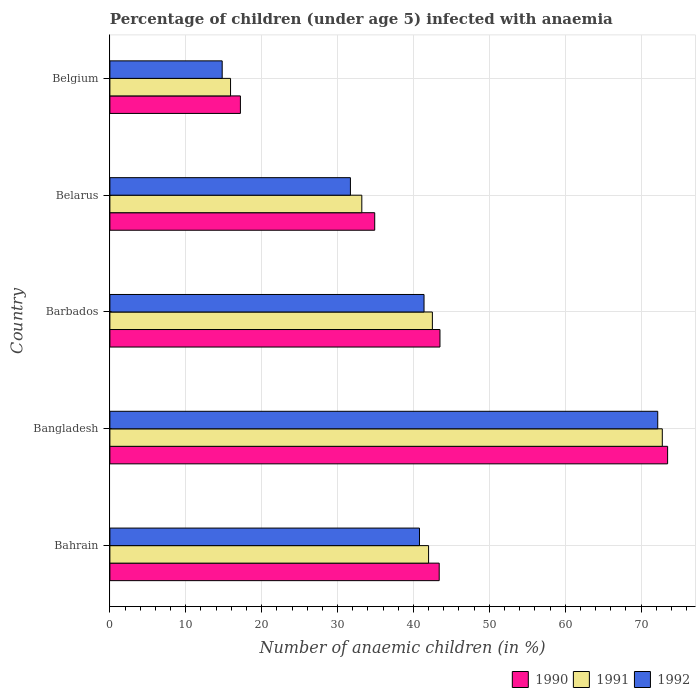Are the number of bars per tick equal to the number of legend labels?
Your answer should be very brief. Yes. How many bars are there on the 3rd tick from the top?
Make the answer very short. 3. How many bars are there on the 2nd tick from the bottom?
Your answer should be compact. 3. What is the label of the 5th group of bars from the top?
Provide a succinct answer. Bahrain. In how many cases, is the number of bars for a given country not equal to the number of legend labels?
Provide a short and direct response. 0. What is the percentage of children infected with anaemia in in 1990 in Belarus?
Ensure brevity in your answer.  34.9. Across all countries, what is the maximum percentage of children infected with anaemia in in 1991?
Your response must be concise. 72.8. Across all countries, what is the minimum percentage of children infected with anaemia in in 1991?
Your response must be concise. 15.9. What is the total percentage of children infected with anaemia in in 1991 in the graph?
Make the answer very short. 206.4. What is the difference between the percentage of children infected with anaemia in in 1991 in Bangladesh and that in Barbados?
Keep it short and to the point. 30.3. What is the difference between the percentage of children infected with anaemia in in 1991 in Bangladesh and the percentage of children infected with anaemia in in 1992 in Barbados?
Give a very brief answer. 31.4. What is the average percentage of children infected with anaemia in in 1991 per country?
Keep it short and to the point. 41.28. What is the difference between the percentage of children infected with anaemia in in 1990 and percentage of children infected with anaemia in in 1991 in Bangladesh?
Give a very brief answer. 0.7. In how many countries, is the percentage of children infected with anaemia in in 1991 greater than 16 %?
Provide a short and direct response. 4. What is the ratio of the percentage of children infected with anaemia in in 1990 in Belarus to that in Belgium?
Give a very brief answer. 2.03. Is the percentage of children infected with anaemia in in 1991 in Bangladesh less than that in Belarus?
Give a very brief answer. No. What is the difference between the highest and the lowest percentage of children infected with anaemia in in 1992?
Provide a succinct answer. 57.4. Is the sum of the percentage of children infected with anaemia in in 1992 in Bahrain and Belarus greater than the maximum percentage of children infected with anaemia in in 1990 across all countries?
Provide a succinct answer. No. What does the 2nd bar from the top in Bahrain represents?
Offer a very short reply. 1991. Is it the case that in every country, the sum of the percentage of children infected with anaemia in in 1990 and percentage of children infected with anaemia in in 1992 is greater than the percentage of children infected with anaemia in in 1991?
Provide a short and direct response. Yes. What is the difference between two consecutive major ticks on the X-axis?
Your response must be concise. 10. Does the graph contain grids?
Your response must be concise. Yes. How many legend labels are there?
Provide a short and direct response. 3. What is the title of the graph?
Provide a short and direct response. Percentage of children (under age 5) infected with anaemia. What is the label or title of the X-axis?
Keep it short and to the point. Number of anaemic children (in %). What is the label or title of the Y-axis?
Give a very brief answer. Country. What is the Number of anaemic children (in %) in 1990 in Bahrain?
Keep it short and to the point. 43.4. What is the Number of anaemic children (in %) in 1992 in Bahrain?
Your answer should be compact. 40.8. What is the Number of anaemic children (in %) in 1990 in Bangladesh?
Offer a terse response. 73.5. What is the Number of anaemic children (in %) in 1991 in Bangladesh?
Keep it short and to the point. 72.8. What is the Number of anaemic children (in %) of 1992 in Bangladesh?
Provide a succinct answer. 72.2. What is the Number of anaemic children (in %) of 1990 in Barbados?
Make the answer very short. 43.5. What is the Number of anaemic children (in %) of 1991 in Barbados?
Your answer should be compact. 42.5. What is the Number of anaemic children (in %) in 1992 in Barbados?
Your answer should be very brief. 41.4. What is the Number of anaemic children (in %) of 1990 in Belarus?
Ensure brevity in your answer.  34.9. What is the Number of anaemic children (in %) of 1991 in Belarus?
Provide a succinct answer. 33.2. What is the Number of anaemic children (in %) of 1992 in Belarus?
Give a very brief answer. 31.7. What is the Number of anaemic children (in %) in 1990 in Belgium?
Keep it short and to the point. 17.2. What is the Number of anaemic children (in %) in 1991 in Belgium?
Give a very brief answer. 15.9. What is the Number of anaemic children (in %) in 1992 in Belgium?
Your response must be concise. 14.8. Across all countries, what is the maximum Number of anaemic children (in %) of 1990?
Your answer should be very brief. 73.5. Across all countries, what is the maximum Number of anaemic children (in %) in 1991?
Provide a short and direct response. 72.8. Across all countries, what is the maximum Number of anaemic children (in %) of 1992?
Offer a terse response. 72.2. Across all countries, what is the minimum Number of anaemic children (in %) of 1990?
Keep it short and to the point. 17.2. Across all countries, what is the minimum Number of anaemic children (in %) in 1991?
Offer a very short reply. 15.9. Across all countries, what is the minimum Number of anaemic children (in %) in 1992?
Ensure brevity in your answer.  14.8. What is the total Number of anaemic children (in %) in 1990 in the graph?
Provide a succinct answer. 212.5. What is the total Number of anaemic children (in %) of 1991 in the graph?
Your answer should be very brief. 206.4. What is the total Number of anaemic children (in %) in 1992 in the graph?
Make the answer very short. 200.9. What is the difference between the Number of anaemic children (in %) of 1990 in Bahrain and that in Bangladesh?
Make the answer very short. -30.1. What is the difference between the Number of anaemic children (in %) in 1991 in Bahrain and that in Bangladesh?
Keep it short and to the point. -30.8. What is the difference between the Number of anaemic children (in %) of 1992 in Bahrain and that in Bangladesh?
Provide a short and direct response. -31.4. What is the difference between the Number of anaemic children (in %) in 1990 in Bahrain and that in Barbados?
Ensure brevity in your answer.  -0.1. What is the difference between the Number of anaemic children (in %) in 1990 in Bahrain and that in Belarus?
Your response must be concise. 8.5. What is the difference between the Number of anaemic children (in %) in 1991 in Bahrain and that in Belarus?
Ensure brevity in your answer.  8.8. What is the difference between the Number of anaemic children (in %) of 1990 in Bahrain and that in Belgium?
Offer a terse response. 26.2. What is the difference between the Number of anaemic children (in %) of 1991 in Bahrain and that in Belgium?
Keep it short and to the point. 26.1. What is the difference between the Number of anaemic children (in %) of 1992 in Bahrain and that in Belgium?
Provide a succinct answer. 26. What is the difference between the Number of anaemic children (in %) of 1990 in Bangladesh and that in Barbados?
Your answer should be very brief. 30. What is the difference between the Number of anaemic children (in %) of 1991 in Bangladesh and that in Barbados?
Give a very brief answer. 30.3. What is the difference between the Number of anaemic children (in %) in 1992 in Bangladesh and that in Barbados?
Your response must be concise. 30.8. What is the difference between the Number of anaemic children (in %) of 1990 in Bangladesh and that in Belarus?
Offer a terse response. 38.6. What is the difference between the Number of anaemic children (in %) in 1991 in Bangladesh and that in Belarus?
Your answer should be very brief. 39.6. What is the difference between the Number of anaemic children (in %) in 1992 in Bangladesh and that in Belarus?
Offer a very short reply. 40.5. What is the difference between the Number of anaemic children (in %) of 1990 in Bangladesh and that in Belgium?
Provide a short and direct response. 56.3. What is the difference between the Number of anaemic children (in %) in 1991 in Bangladesh and that in Belgium?
Give a very brief answer. 56.9. What is the difference between the Number of anaemic children (in %) of 1992 in Bangladesh and that in Belgium?
Offer a terse response. 57.4. What is the difference between the Number of anaemic children (in %) of 1990 in Barbados and that in Belarus?
Offer a very short reply. 8.6. What is the difference between the Number of anaemic children (in %) in 1991 in Barbados and that in Belarus?
Offer a very short reply. 9.3. What is the difference between the Number of anaemic children (in %) of 1990 in Barbados and that in Belgium?
Your answer should be compact. 26.3. What is the difference between the Number of anaemic children (in %) of 1991 in Barbados and that in Belgium?
Offer a terse response. 26.6. What is the difference between the Number of anaemic children (in %) in 1992 in Barbados and that in Belgium?
Ensure brevity in your answer.  26.6. What is the difference between the Number of anaemic children (in %) in 1990 in Belarus and that in Belgium?
Offer a terse response. 17.7. What is the difference between the Number of anaemic children (in %) of 1990 in Bahrain and the Number of anaemic children (in %) of 1991 in Bangladesh?
Give a very brief answer. -29.4. What is the difference between the Number of anaemic children (in %) in 1990 in Bahrain and the Number of anaemic children (in %) in 1992 in Bangladesh?
Give a very brief answer. -28.8. What is the difference between the Number of anaemic children (in %) of 1991 in Bahrain and the Number of anaemic children (in %) of 1992 in Bangladesh?
Your answer should be compact. -30.2. What is the difference between the Number of anaemic children (in %) in 1990 in Bahrain and the Number of anaemic children (in %) in 1991 in Barbados?
Provide a short and direct response. 0.9. What is the difference between the Number of anaemic children (in %) of 1990 in Bahrain and the Number of anaemic children (in %) of 1992 in Belarus?
Make the answer very short. 11.7. What is the difference between the Number of anaemic children (in %) in 1990 in Bahrain and the Number of anaemic children (in %) in 1992 in Belgium?
Keep it short and to the point. 28.6. What is the difference between the Number of anaemic children (in %) in 1991 in Bahrain and the Number of anaemic children (in %) in 1992 in Belgium?
Provide a succinct answer. 27.2. What is the difference between the Number of anaemic children (in %) in 1990 in Bangladesh and the Number of anaemic children (in %) in 1992 in Barbados?
Make the answer very short. 32.1. What is the difference between the Number of anaemic children (in %) of 1991 in Bangladesh and the Number of anaemic children (in %) of 1992 in Barbados?
Your answer should be very brief. 31.4. What is the difference between the Number of anaemic children (in %) in 1990 in Bangladesh and the Number of anaemic children (in %) in 1991 in Belarus?
Offer a terse response. 40.3. What is the difference between the Number of anaemic children (in %) in 1990 in Bangladesh and the Number of anaemic children (in %) in 1992 in Belarus?
Make the answer very short. 41.8. What is the difference between the Number of anaemic children (in %) in 1991 in Bangladesh and the Number of anaemic children (in %) in 1992 in Belarus?
Provide a short and direct response. 41.1. What is the difference between the Number of anaemic children (in %) in 1990 in Bangladesh and the Number of anaemic children (in %) in 1991 in Belgium?
Offer a very short reply. 57.6. What is the difference between the Number of anaemic children (in %) of 1990 in Bangladesh and the Number of anaemic children (in %) of 1992 in Belgium?
Give a very brief answer. 58.7. What is the difference between the Number of anaemic children (in %) of 1991 in Bangladesh and the Number of anaemic children (in %) of 1992 in Belgium?
Provide a succinct answer. 58. What is the difference between the Number of anaemic children (in %) in 1990 in Barbados and the Number of anaemic children (in %) in 1991 in Belarus?
Offer a very short reply. 10.3. What is the difference between the Number of anaemic children (in %) of 1990 in Barbados and the Number of anaemic children (in %) of 1992 in Belarus?
Your answer should be very brief. 11.8. What is the difference between the Number of anaemic children (in %) in 1990 in Barbados and the Number of anaemic children (in %) in 1991 in Belgium?
Give a very brief answer. 27.6. What is the difference between the Number of anaemic children (in %) of 1990 in Barbados and the Number of anaemic children (in %) of 1992 in Belgium?
Provide a short and direct response. 28.7. What is the difference between the Number of anaemic children (in %) in 1991 in Barbados and the Number of anaemic children (in %) in 1992 in Belgium?
Keep it short and to the point. 27.7. What is the difference between the Number of anaemic children (in %) in 1990 in Belarus and the Number of anaemic children (in %) in 1992 in Belgium?
Ensure brevity in your answer.  20.1. What is the average Number of anaemic children (in %) of 1990 per country?
Ensure brevity in your answer.  42.5. What is the average Number of anaemic children (in %) of 1991 per country?
Offer a very short reply. 41.28. What is the average Number of anaemic children (in %) in 1992 per country?
Your answer should be very brief. 40.18. What is the difference between the Number of anaemic children (in %) in 1990 and Number of anaemic children (in %) in 1991 in Bangladesh?
Your response must be concise. 0.7. What is the difference between the Number of anaemic children (in %) of 1990 and Number of anaemic children (in %) of 1992 in Bangladesh?
Offer a very short reply. 1.3. What is the difference between the Number of anaemic children (in %) in 1990 and Number of anaemic children (in %) in 1991 in Barbados?
Ensure brevity in your answer.  1. What is the difference between the Number of anaemic children (in %) in 1990 and Number of anaemic children (in %) in 1992 in Barbados?
Give a very brief answer. 2.1. What is the difference between the Number of anaemic children (in %) of 1991 and Number of anaemic children (in %) of 1992 in Barbados?
Make the answer very short. 1.1. What is the difference between the Number of anaemic children (in %) in 1990 and Number of anaemic children (in %) in 1991 in Belarus?
Provide a succinct answer. 1.7. What is the difference between the Number of anaemic children (in %) in 1990 and Number of anaemic children (in %) in 1992 in Belarus?
Offer a very short reply. 3.2. What is the difference between the Number of anaemic children (in %) of 1991 and Number of anaemic children (in %) of 1992 in Belarus?
Your answer should be compact. 1.5. What is the difference between the Number of anaemic children (in %) in 1990 and Number of anaemic children (in %) in 1991 in Belgium?
Offer a terse response. 1.3. What is the difference between the Number of anaemic children (in %) of 1991 and Number of anaemic children (in %) of 1992 in Belgium?
Ensure brevity in your answer.  1.1. What is the ratio of the Number of anaemic children (in %) of 1990 in Bahrain to that in Bangladesh?
Ensure brevity in your answer.  0.59. What is the ratio of the Number of anaemic children (in %) in 1991 in Bahrain to that in Bangladesh?
Make the answer very short. 0.58. What is the ratio of the Number of anaemic children (in %) in 1992 in Bahrain to that in Bangladesh?
Your answer should be very brief. 0.57. What is the ratio of the Number of anaemic children (in %) of 1991 in Bahrain to that in Barbados?
Provide a succinct answer. 0.99. What is the ratio of the Number of anaemic children (in %) in 1992 in Bahrain to that in Barbados?
Offer a very short reply. 0.99. What is the ratio of the Number of anaemic children (in %) of 1990 in Bahrain to that in Belarus?
Keep it short and to the point. 1.24. What is the ratio of the Number of anaemic children (in %) in 1991 in Bahrain to that in Belarus?
Keep it short and to the point. 1.27. What is the ratio of the Number of anaemic children (in %) of 1992 in Bahrain to that in Belarus?
Your answer should be compact. 1.29. What is the ratio of the Number of anaemic children (in %) of 1990 in Bahrain to that in Belgium?
Your answer should be compact. 2.52. What is the ratio of the Number of anaemic children (in %) in 1991 in Bahrain to that in Belgium?
Ensure brevity in your answer.  2.64. What is the ratio of the Number of anaemic children (in %) of 1992 in Bahrain to that in Belgium?
Offer a very short reply. 2.76. What is the ratio of the Number of anaemic children (in %) of 1990 in Bangladesh to that in Barbados?
Make the answer very short. 1.69. What is the ratio of the Number of anaemic children (in %) of 1991 in Bangladesh to that in Barbados?
Ensure brevity in your answer.  1.71. What is the ratio of the Number of anaemic children (in %) of 1992 in Bangladesh to that in Barbados?
Provide a short and direct response. 1.74. What is the ratio of the Number of anaemic children (in %) in 1990 in Bangladesh to that in Belarus?
Make the answer very short. 2.11. What is the ratio of the Number of anaemic children (in %) of 1991 in Bangladesh to that in Belarus?
Offer a terse response. 2.19. What is the ratio of the Number of anaemic children (in %) in 1992 in Bangladesh to that in Belarus?
Your answer should be very brief. 2.28. What is the ratio of the Number of anaemic children (in %) in 1990 in Bangladesh to that in Belgium?
Provide a succinct answer. 4.27. What is the ratio of the Number of anaemic children (in %) of 1991 in Bangladesh to that in Belgium?
Ensure brevity in your answer.  4.58. What is the ratio of the Number of anaemic children (in %) of 1992 in Bangladesh to that in Belgium?
Offer a very short reply. 4.88. What is the ratio of the Number of anaemic children (in %) of 1990 in Barbados to that in Belarus?
Give a very brief answer. 1.25. What is the ratio of the Number of anaemic children (in %) of 1991 in Barbados to that in Belarus?
Your answer should be very brief. 1.28. What is the ratio of the Number of anaemic children (in %) of 1992 in Barbados to that in Belarus?
Your answer should be compact. 1.31. What is the ratio of the Number of anaemic children (in %) of 1990 in Barbados to that in Belgium?
Your response must be concise. 2.53. What is the ratio of the Number of anaemic children (in %) in 1991 in Barbados to that in Belgium?
Give a very brief answer. 2.67. What is the ratio of the Number of anaemic children (in %) of 1992 in Barbados to that in Belgium?
Give a very brief answer. 2.8. What is the ratio of the Number of anaemic children (in %) of 1990 in Belarus to that in Belgium?
Your response must be concise. 2.03. What is the ratio of the Number of anaemic children (in %) of 1991 in Belarus to that in Belgium?
Provide a succinct answer. 2.09. What is the ratio of the Number of anaemic children (in %) of 1992 in Belarus to that in Belgium?
Offer a very short reply. 2.14. What is the difference between the highest and the second highest Number of anaemic children (in %) of 1990?
Keep it short and to the point. 30. What is the difference between the highest and the second highest Number of anaemic children (in %) in 1991?
Your answer should be compact. 30.3. What is the difference between the highest and the second highest Number of anaemic children (in %) in 1992?
Give a very brief answer. 30.8. What is the difference between the highest and the lowest Number of anaemic children (in %) of 1990?
Offer a terse response. 56.3. What is the difference between the highest and the lowest Number of anaemic children (in %) of 1991?
Offer a very short reply. 56.9. What is the difference between the highest and the lowest Number of anaemic children (in %) of 1992?
Provide a succinct answer. 57.4. 